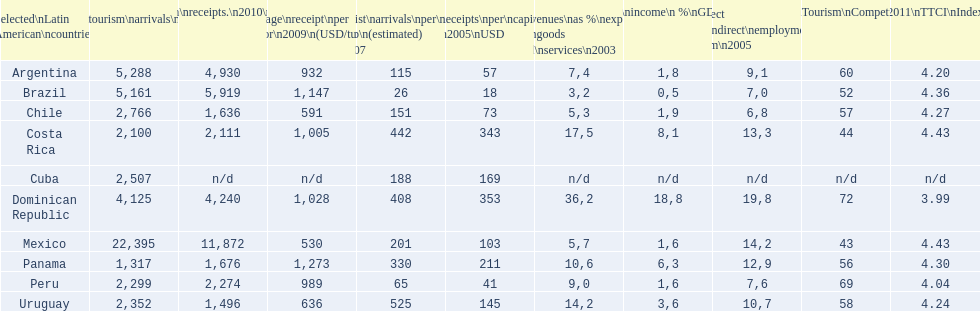Which nation had the greatest per capita receipts in 2005? Dominican Republic. 